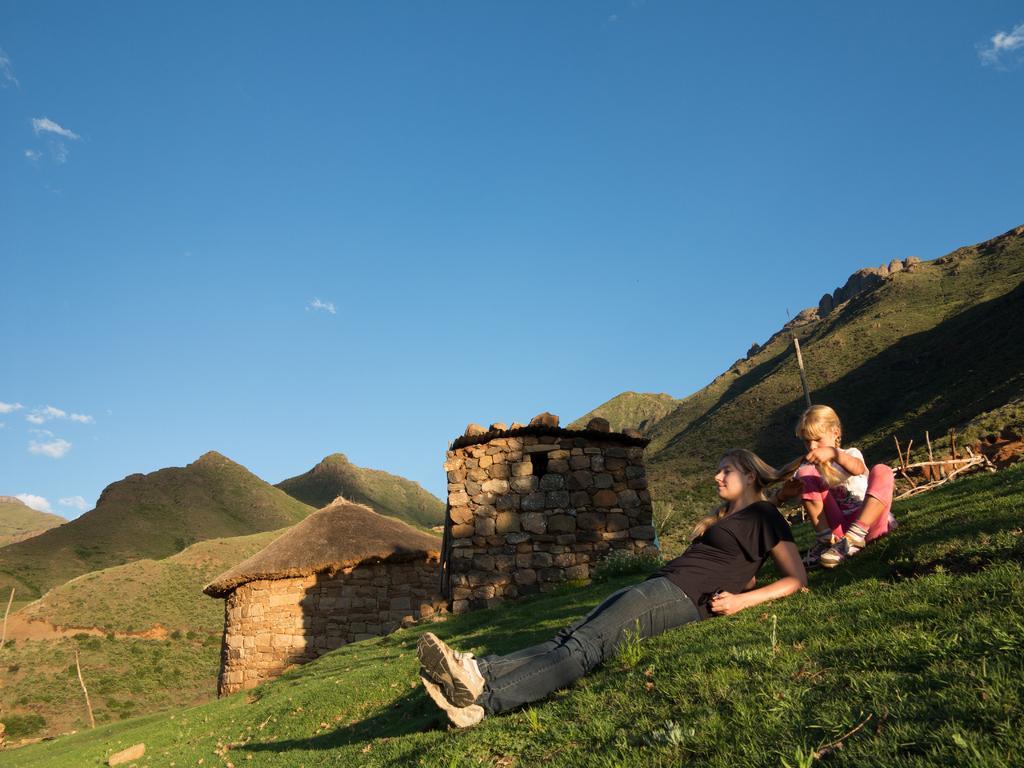Could you give a brief overview of what you see in this image? This is the woman lying and a girl sitting. I can see the grass. I think these are the huts. I can see the hills. This is the sky. 